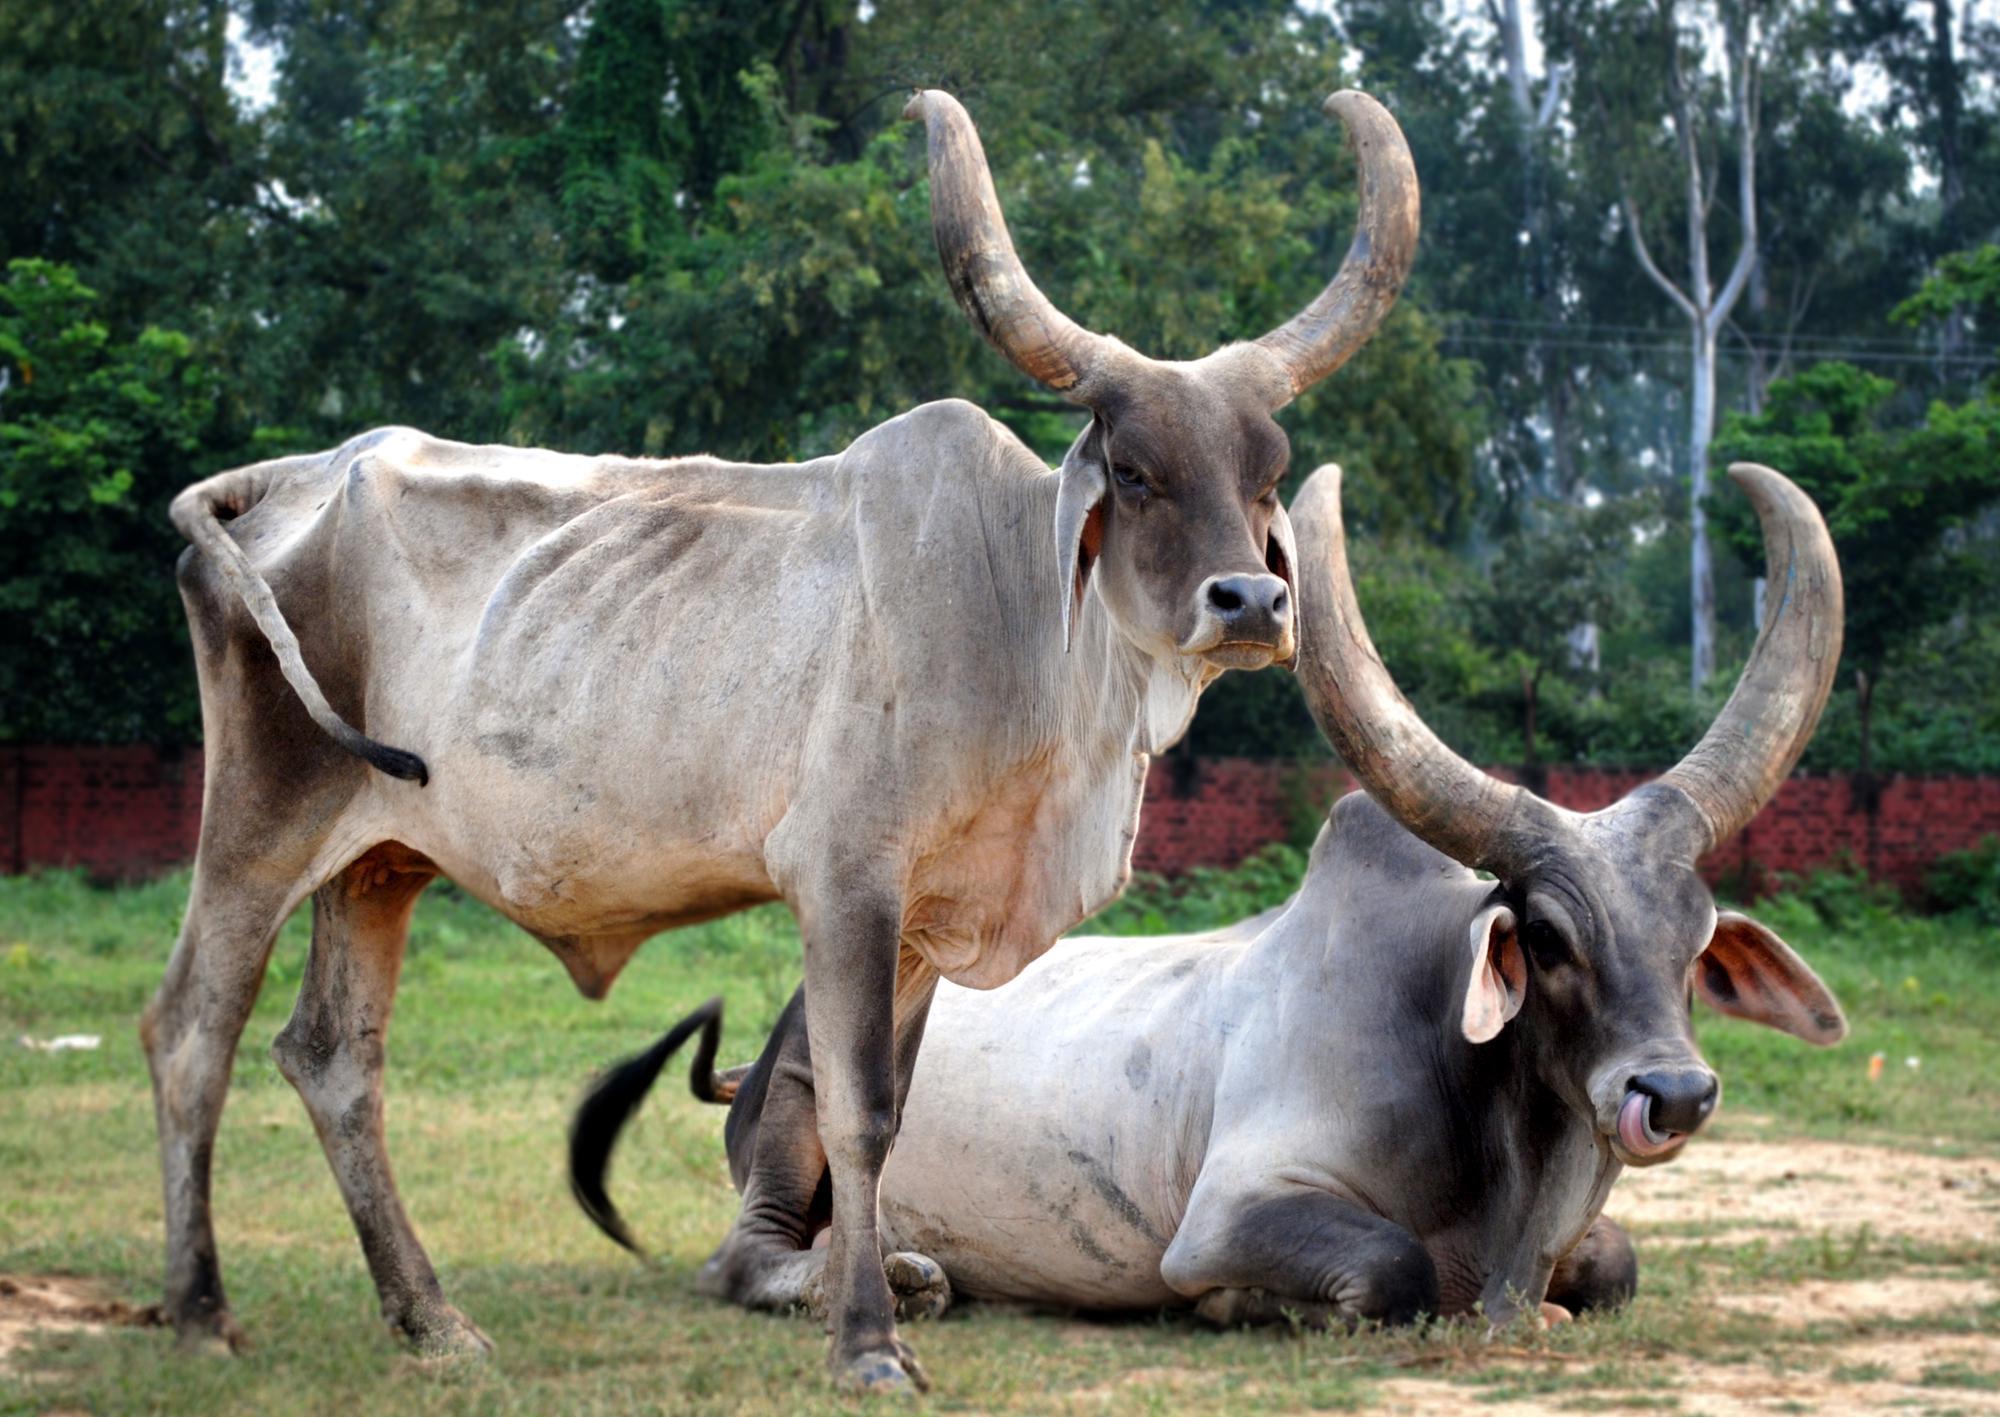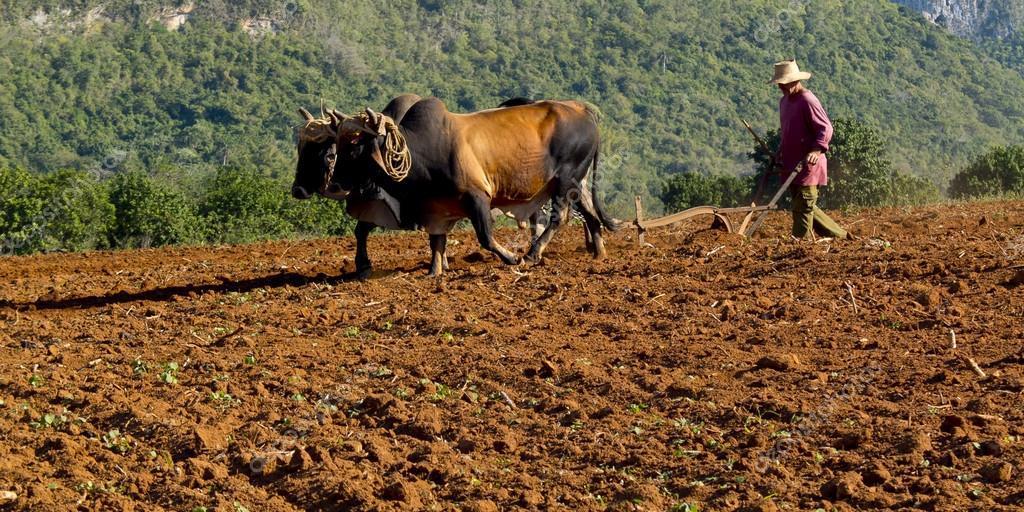The first image is the image on the left, the second image is the image on the right. Considering the images on both sides, is "Both images show cows plowing a field." valid? Answer yes or no. No. The first image is the image on the left, the second image is the image on the right. Examine the images to the left and right. Is the description "One image shows two brown cattle wearing a wooden plow hitch and angled rightward, and the other image shows a person standing behind a team of two cattle." accurate? Answer yes or no. No. 